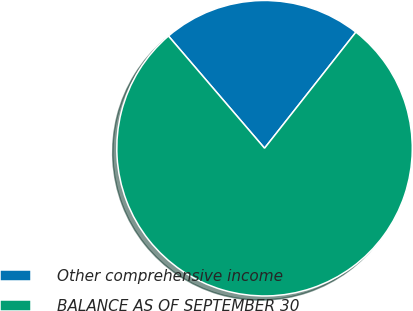Convert chart. <chart><loc_0><loc_0><loc_500><loc_500><pie_chart><fcel>Other comprehensive income<fcel>BALANCE AS OF SEPTEMBER 30<nl><fcel>21.88%<fcel>78.12%<nl></chart> 